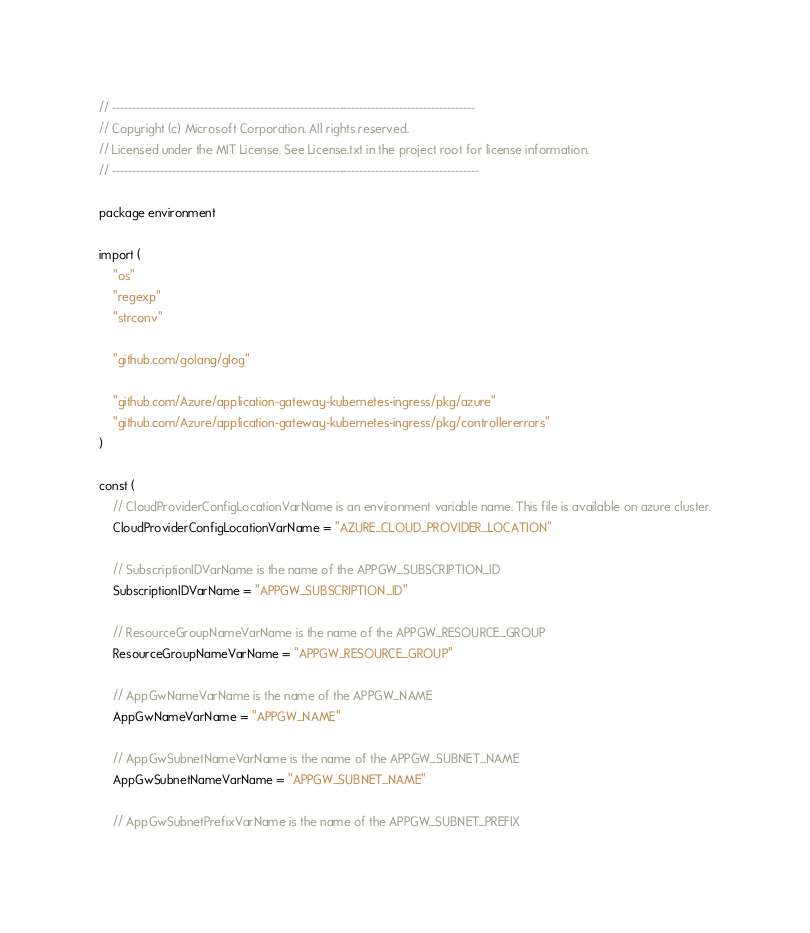<code> <loc_0><loc_0><loc_500><loc_500><_Go_>// -------------------------------------------------------------------------------------------
// Copyright (c) Microsoft Corporation. All rights reserved.
// Licensed under the MIT License. See License.txt in the project root for license information.
// --------------------------------------------------------------------------------------------

package environment

import (
	"os"
	"regexp"
	"strconv"

	"github.com/golang/glog"

	"github.com/Azure/application-gateway-kubernetes-ingress/pkg/azure"
	"github.com/Azure/application-gateway-kubernetes-ingress/pkg/controllererrors"
)

const (
	// CloudProviderConfigLocationVarName is an environment variable name. This file is available on azure cluster.
	CloudProviderConfigLocationVarName = "AZURE_CLOUD_PROVIDER_LOCATION"

	// SubscriptionIDVarName is the name of the APPGW_SUBSCRIPTION_ID
	SubscriptionIDVarName = "APPGW_SUBSCRIPTION_ID"

	// ResourceGroupNameVarName is the name of the APPGW_RESOURCE_GROUP
	ResourceGroupNameVarName = "APPGW_RESOURCE_GROUP"

	// AppGwNameVarName is the name of the APPGW_NAME
	AppGwNameVarName = "APPGW_NAME"

	// AppGwSubnetNameVarName is the name of the APPGW_SUBNET_NAME
	AppGwSubnetNameVarName = "APPGW_SUBNET_NAME"

	// AppGwSubnetPrefixVarName is the name of the APPGW_SUBNET_PREFIX</code> 